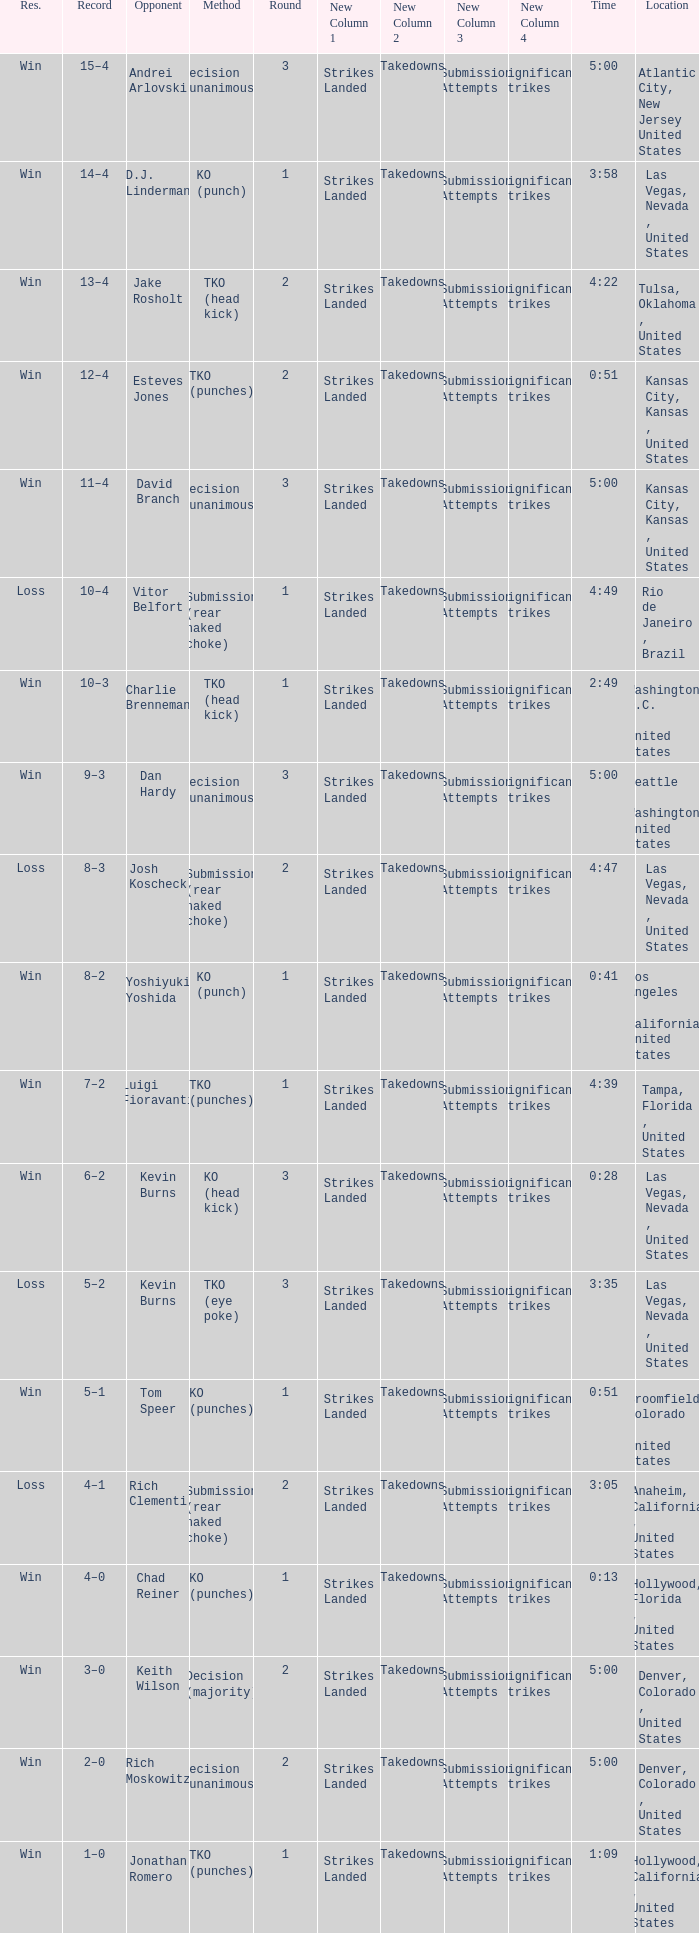What is the result for rounds under 2 against D.J. Linderman? Win. 